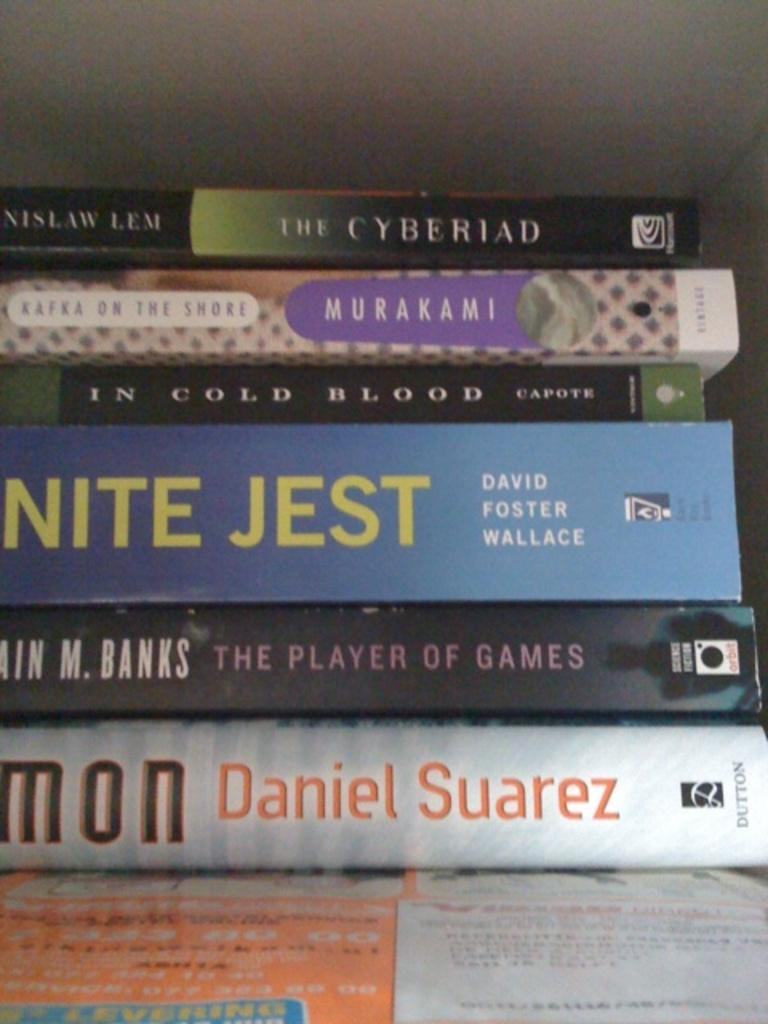What objects are present in the image? There are books in the image. What can be found on the books? The books have text printed on them. How many hairs can be seen on the geese in the image? There are no geese present in the image, so it is not possible to determine the number of hairs on any geese. 